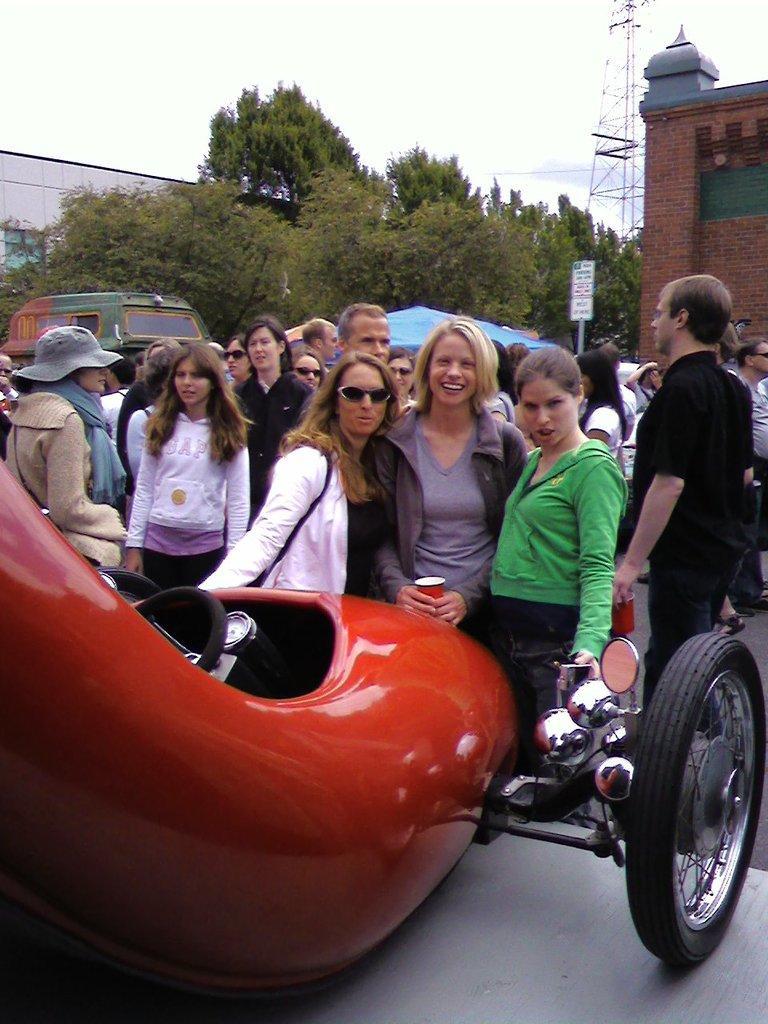In one or two sentences, can you explain what this image depicts? In the image I can see a group of people are standing on the road. In the background I can see vehicles, trees, buildings, a tower, the sky and some other objects. Here I can see a red color vehicle on the road. 